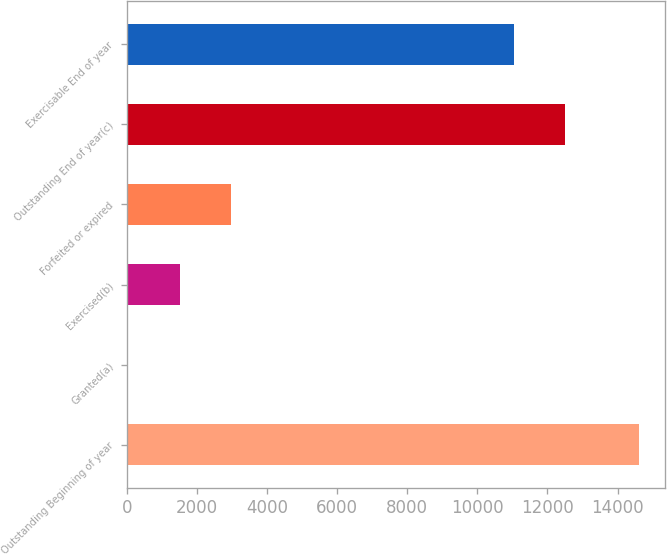Convert chart. <chart><loc_0><loc_0><loc_500><loc_500><bar_chart><fcel>Outstanding Beginning of year<fcel>Granted(a)<fcel>Exercised(b)<fcel>Forfeited or expired<fcel>Outstanding End of year(c)<fcel>Exercisable End of year<nl><fcel>14620<fcel>6<fcel>1506<fcel>2967.4<fcel>12505.4<fcel>11044<nl></chart> 